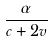Convert formula to latex. <formula><loc_0><loc_0><loc_500><loc_500>\frac { \alpha } { c + 2 v }</formula> 